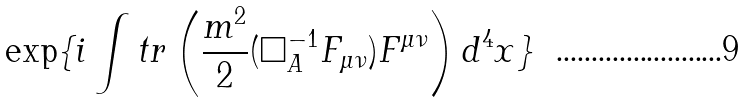Convert formula to latex. <formula><loc_0><loc_0><loc_500><loc_500>\exp \{ i \int t r \left ( \frac { m ^ { 2 } } { 2 } ( \square ^ { - 1 } _ { A } F _ { \mu \nu } ) F ^ { \mu \nu } \right ) d ^ { 4 } x \}</formula> 